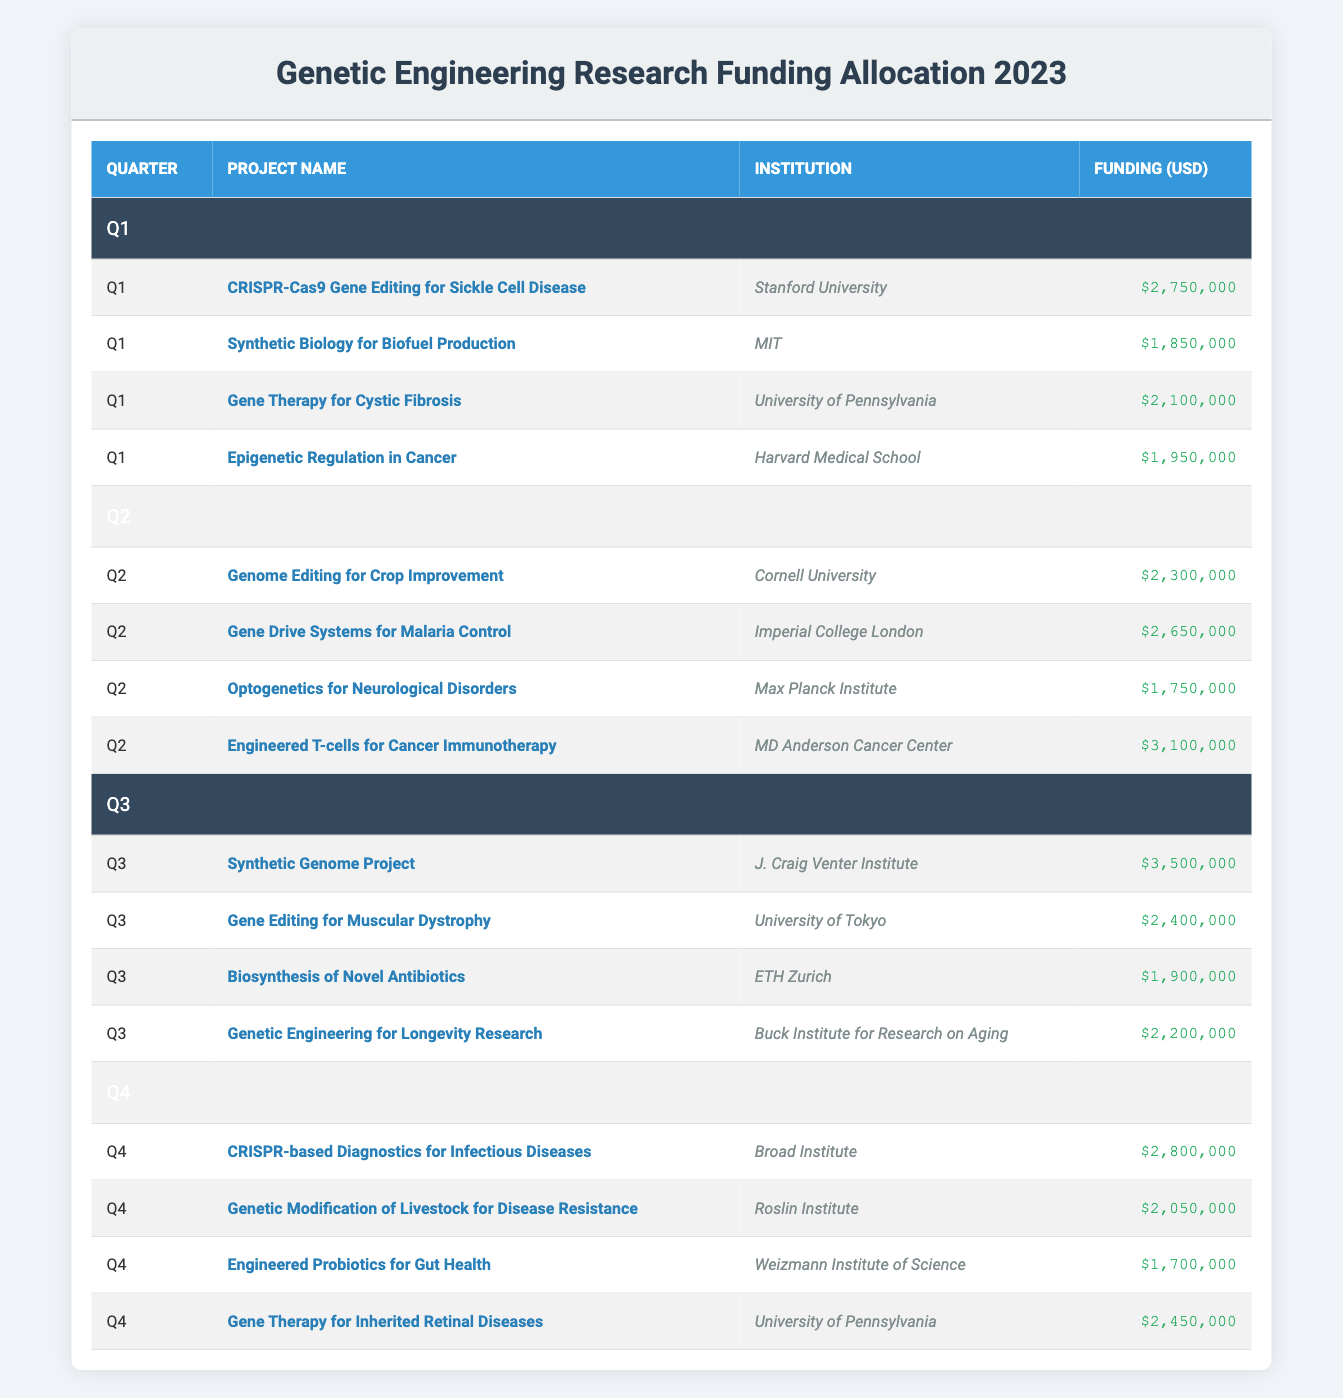What is the total funding allocated in Q1? In Q1, the projects and their funding amounts are: CRISPR-Cas9 Gene Editing for Sickle Cell Disease ($2,750,000), Synthetic Biology for Biofuel Production ($1,850,000), Gene Therapy for Cystic Fibrosis ($2,100,000), and Epigenetic Regulation in Cancer ($1,950,000). The total funding can be calculated by summing these amounts: $2,750,000 + $1,850,000 + $2,100,000 + $1,950,000 = $8,650,000.
Answer: 8,650,000 Which project received the highest funding in Q3? In Q3, the projects and their funding amounts are: Synthetic Genome Project ($3,500,000), Gene Editing for Muscular Dystrophy ($2,400,000), Biosynthesis of Novel Antibiotics ($1,900,000), and Genetic Engineering for Longevity Research ($2,200,000). The highest funding is found by comparing all the funding amounts, which shows that Synthetic Genome Project received the most funding at $3,500,000.
Answer: Synthetic Genome Project Did the project "Genome Editing for Crop Improvement" receive more funding than "Optogenetics for Neurological Disorders"? The funding for "Genome Editing for Crop Improvement" (Q2) is $2,300,000 and for "Optogenetics for Neurological Disorders" (Q2) is $1,750,000. Comparing these values, $2,300,000 is greater than $1,750,000. Therefore, the statement is true.
Answer: Yes What is the average funding allocated across all quarters for "Gene Therapy" projects? The funding for "Gene Therapy" projects is from the following entries: Gene Therapy for Cystic Fibrosis ($2,100,000) in Q1, and Gene Therapy for Inherited Retinal Diseases ($2,450,000) in Q4. The total funding for these projects is $2,100,000 + $2,450,000 = $4,550,000 across 2 projects. The average is therefore $4,550,000 / 2 = $2,275,000.
Answer: 2,275,000 Is "CRISPR-based Diagnostics for Infectious Diseases" the only project funded by the Broad Institute in 2023? According to the table, the only project listed for Broad Institute is "CRISPR-based Diagnostics for Infectious Diseases" in Q4, and there are no other projects from that institution elsewhere in the table. Therefore, the statement is true.
Answer: Yes What is the total funding for all projects led by institutions outside of the U.S. (non-U.S. institutions)? The non-U.S. projects are: Gene Drive Systems for Malaria Control by Imperial College London ($2,650,000), Optogenetics for Neurological Disorders by Max Planck Institute ($1,750,000), Synthetic Genome Project by J. Craig Venter Institute ($3,500,000), and Gene Editing for Muscular Dystrophy by the University of Tokyo ($2,400,000), and Engineered Probiotics for Gut Health by Weizmann Institute of Science ($1,700,000). Adding these amounts: $2,650,000 + $1,750,000 + $3,500,000 + $2,400,000 + $1,700,000 = $13,000,000.
Answer: 13,000,000 